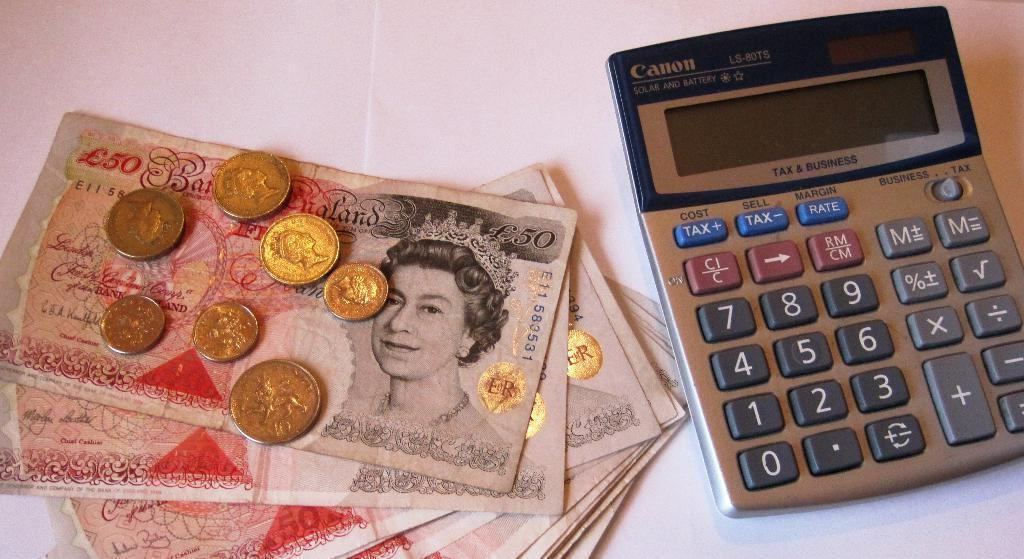<image>
Describe the image concisely. A Canon brand calculator is next to a stack of money. 